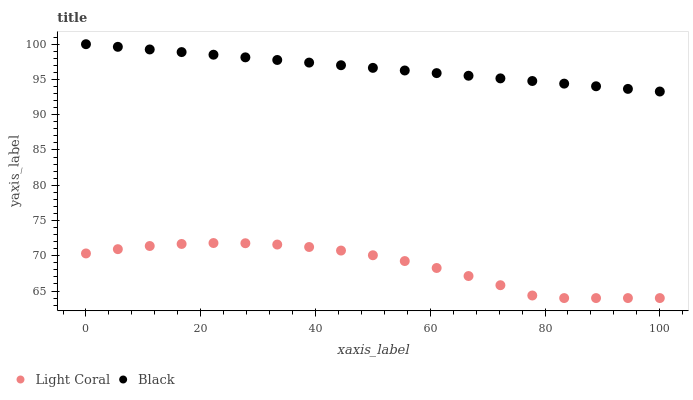Does Light Coral have the minimum area under the curve?
Answer yes or no. Yes. Does Black have the maximum area under the curve?
Answer yes or no. Yes. Does Black have the minimum area under the curve?
Answer yes or no. No. Is Black the smoothest?
Answer yes or no. Yes. Is Light Coral the roughest?
Answer yes or no. Yes. Is Black the roughest?
Answer yes or no. No. Does Light Coral have the lowest value?
Answer yes or no. Yes. Does Black have the lowest value?
Answer yes or no. No. Does Black have the highest value?
Answer yes or no. Yes. Is Light Coral less than Black?
Answer yes or no. Yes. Is Black greater than Light Coral?
Answer yes or no. Yes. Does Light Coral intersect Black?
Answer yes or no. No. 